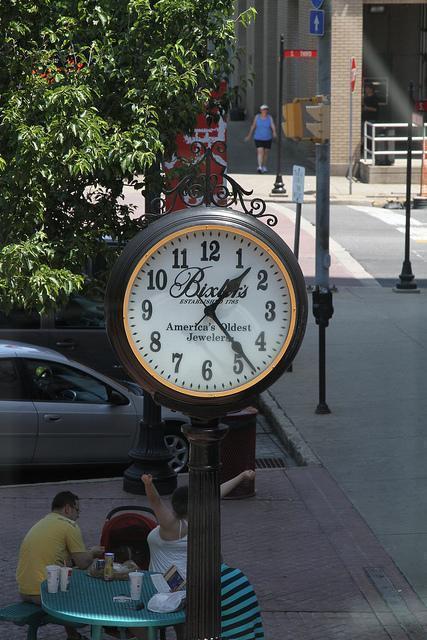What is the highest number that is visible?
Answer the question by selecting the correct answer among the 4 following choices.
Options: 34, 12, 68, 22. 12. 